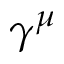Convert formula to latex. <formula><loc_0><loc_0><loc_500><loc_500>\gamma ^ { \mu }</formula> 